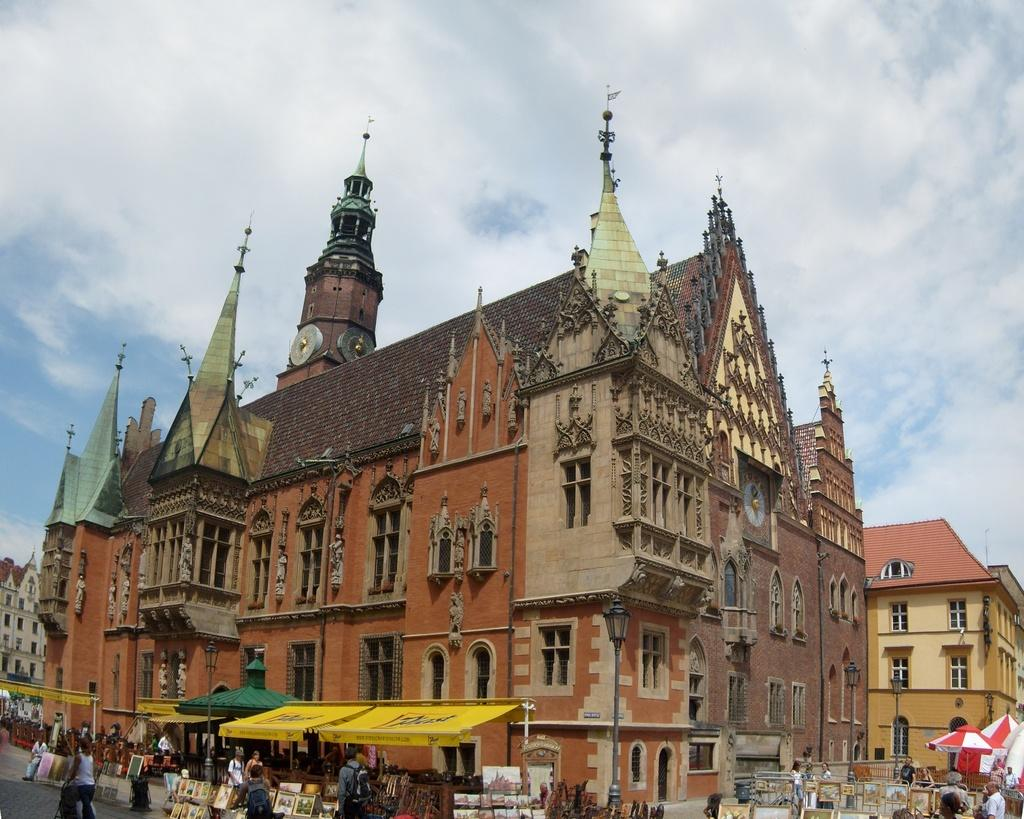What can be seen in the foreground of the image? There are many stalls and persons in the foreground of the image. What is the main structure in the middle of the image? There is a big building in the middle of the image. What colors are used on the building? The building has three colors: brown, red, and cream. What is visible at the top of the image? The sky is visible at the top of the image. Can you tell me how many chickens are on the roof of the building in the image? There are no chickens present on the roof of the building in the image. What type of cloth is draped over the father's shoulder in the image? There is no father or cloth present in the image. 